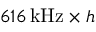<formula> <loc_0><loc_0><loc_500><loc_500>6 1 6 \, k H z \times h</formula> 